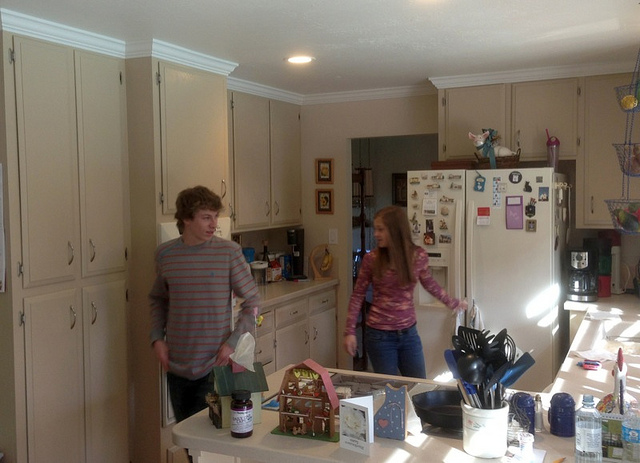<image>What is the condiment in the lower right corner? I am not sure what the condiment in the lower right corner is. It can be either jam, jelly, water, vinegar or mayo. What is the condiment in the lower right corner? I am not sure what the condiment is in the lower right corner. It can be jam, jelly, water, or mayo. 